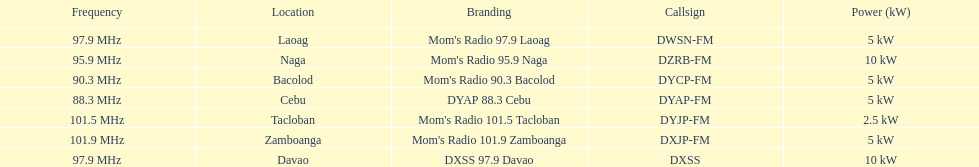Which of these stations broadcasts with the least power? Mom's Radio 101.5 Tacloban. 